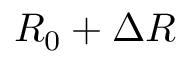Convert formula to latex. <formula><loc_0><loc_0><loc_500><loc_500>R _ { 0 } + \Delta R</formula> 